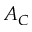<formula> <loc_0><loc_0><loc_500><loc_500>A _ { C }</formula> 